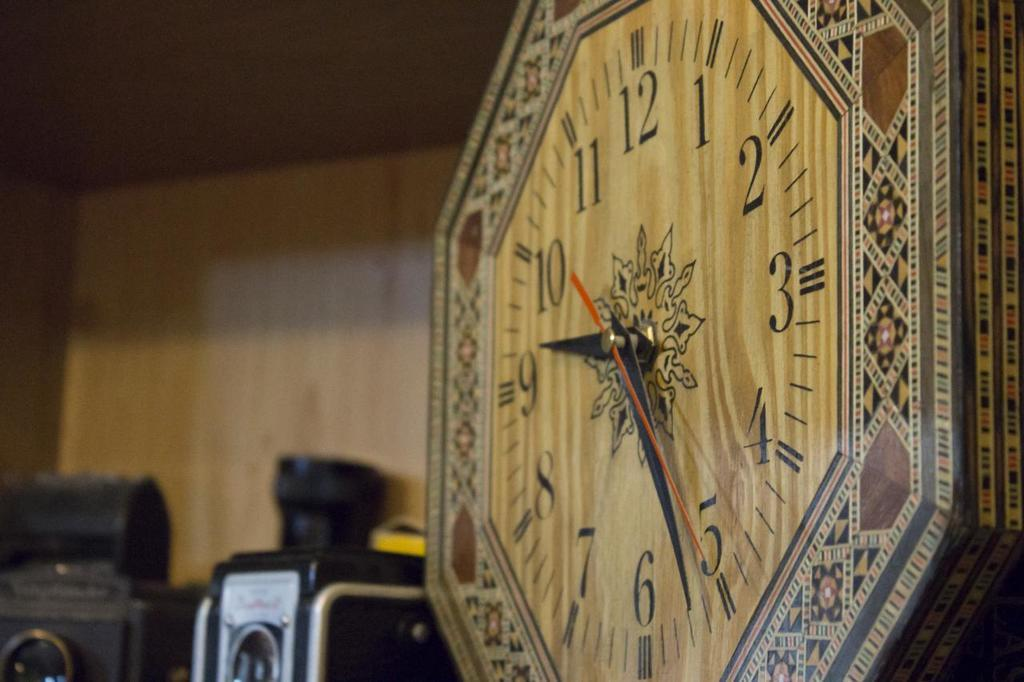<image>
Offer a succinct explanation of the picture presented. a cloick that has 1 to 12 on the front 